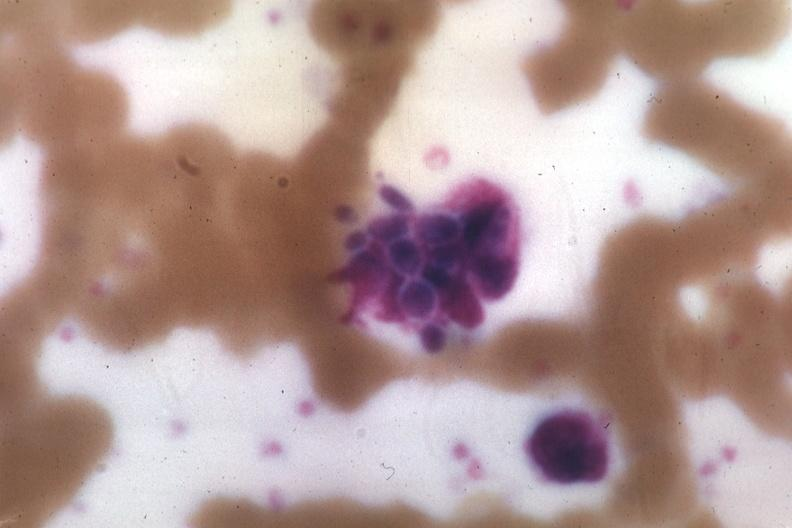what is present?
Answer the question using a single word or phrase. Hematologic 